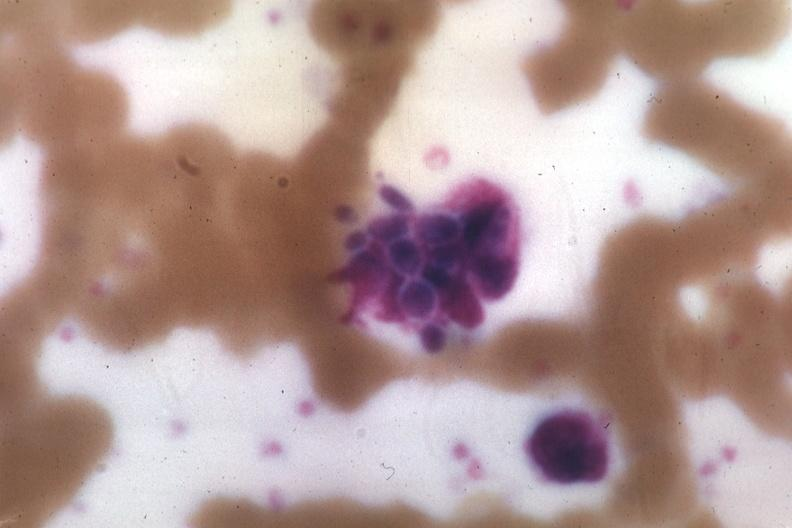what is present?
Answer the question using a single word or phrase. Hematologic 